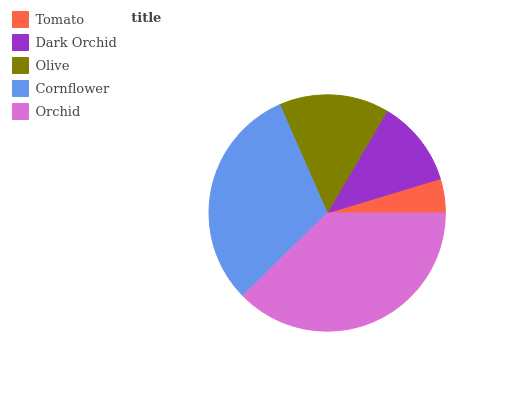Is Tomato the minimum?
Answer yes or no. Yes. Is Orchid the maximum?
Answer yes or no. Yes. Is Dark Orchid the minimum?
Answer yes or no. No. Is Dark Orchid the maximum?
Answer yes or no. No. Is Dark Orchid greater than Tomato?
Answer yes or no. Yes. Is Tomato less than Dark Orchid?
Answer yes or no. Yes. Is Tomato greater than Dark Orchid?
Answer yes or no. No. Is Dark Orchid less than Tomato?
Answer yes or no. No. Is Olive the high median?
Answer yes or no. Yes. Is Olive the low median?
Answer yes or no. Yes. Is Tomato the high median?
Answer yes or no. No. Is Cornflower the low median?
Answer yes or no. No. 